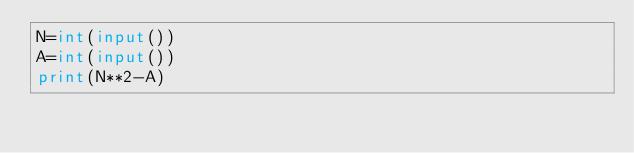<code> <loc_0><loc_0><loc_500><loc_500><_Python_>N=int(input())
A=int(input())
print(N**2-A)</code> 